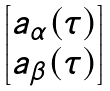<formula> <loc_0><loc_0><loc_500><loc_500>\begin{bmatrix} a _ { \alpha } ( \tau ) \\ a _ { \beta } ( \tau ) \\ \end{bmatrix}</formula> 